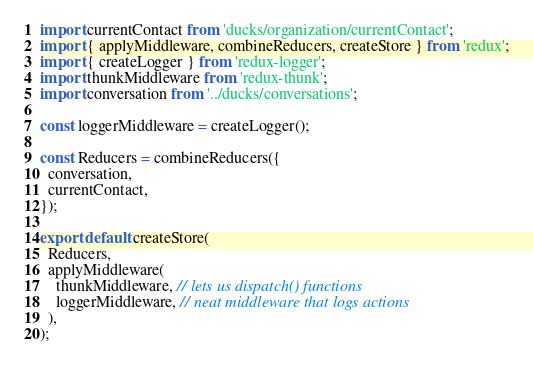Convert code to text. <code><loc_0><loc_0><loc_500><loc_500><_JavaScript_>import currentContact from 'ducks/organization/currentContact';
import { applyMiddleware, combineReducers, createStore } from 'redux';
import { createLogger } from 'redux-logger';
import thunkMiddleware from 'redux-thunk';
import conversation from '../ducks/conversations';

const loggerMiddleware = createLogger();

const Reducers = combineReducers({
  conversation,
  currentContact,
});

export default createStore(
  Reducers,
  applyMiddleware(
    thunkMiddleware, // lets us dispatch() functions
    loggerMiddleware, // neat middleware that logs actions
  ),
);
</code> 